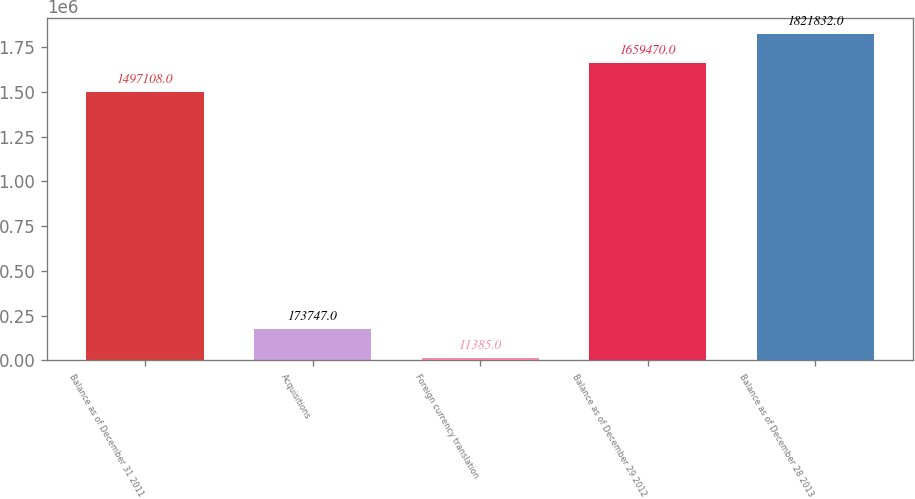Convert chart. <chart><loc_0><loc_0><loc_500><loc_500><bar_chart><fcel>Balance as of December 31 2011<fcel>Acquisitions<fcel>Foreign currency translation<fcel>Balance as of December 29 2012<fcel>Balance as of December 28 2013<nl><fcel>1.49711e+06<fcel>173747<fcel>11385<fcel>1.65947e+06<fcel>1.82183e+06<nl></chart> 